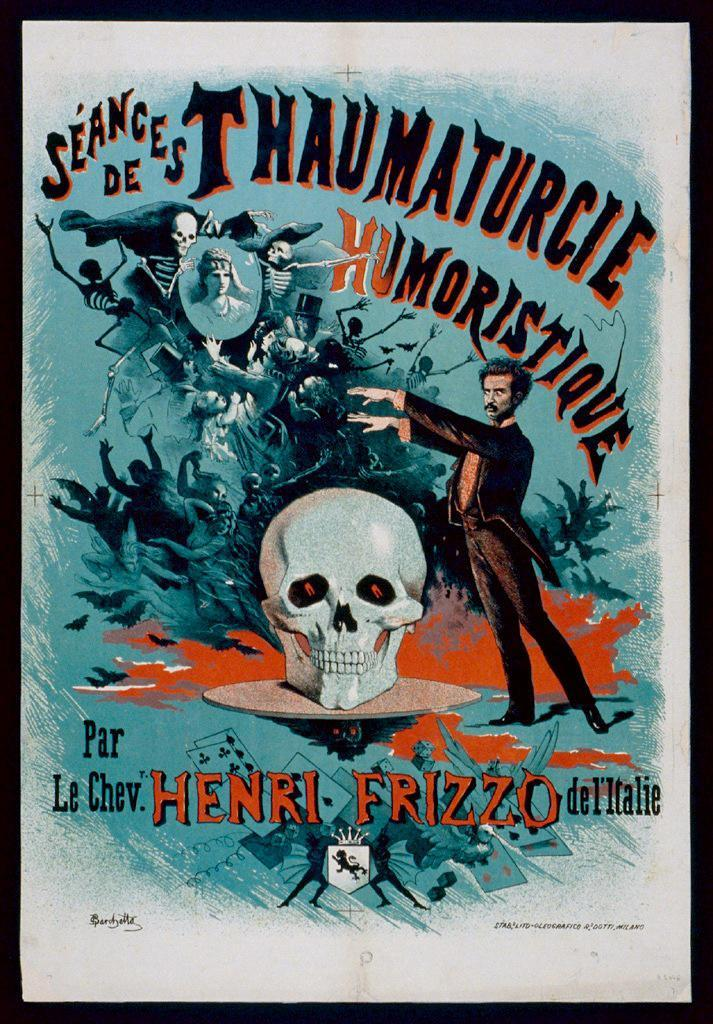Provide a one-sentence caption for the provided image. An old book by Henri Frizzo about Seances. 